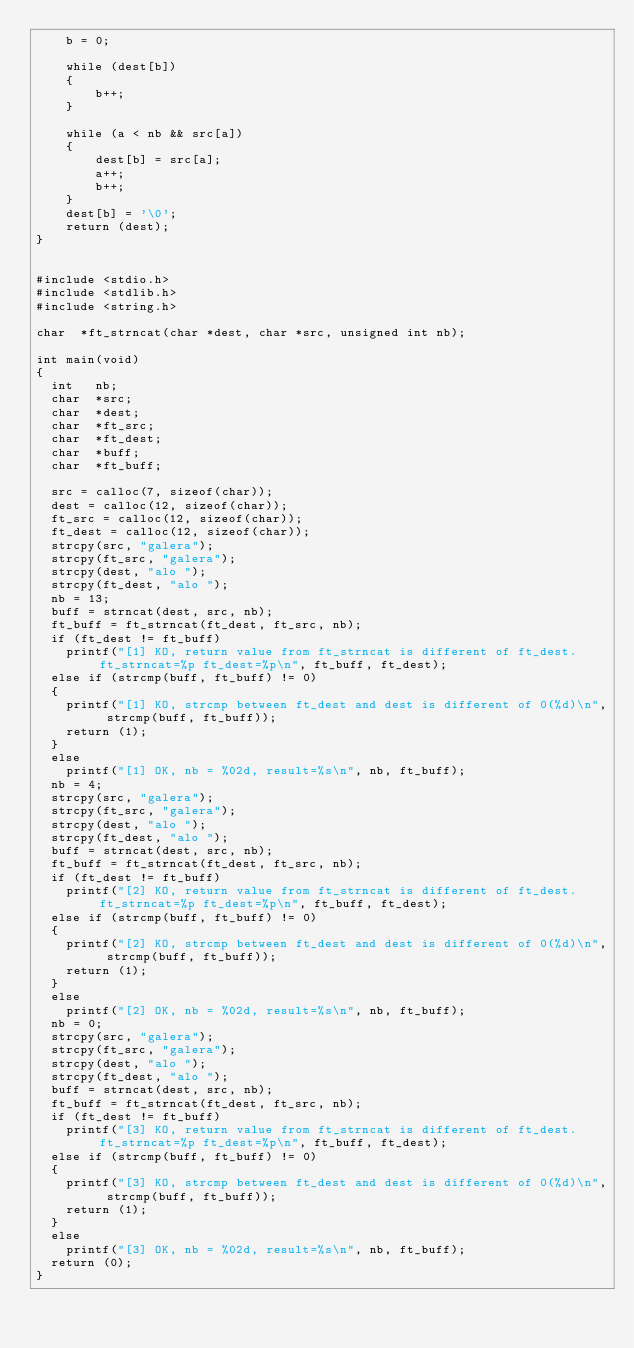<code> <loc_0><loc_0><loc_500><loc_500><_C_>    b = 0;

    while (dest[b])
    {
        b++;
    }

    while (a < nb && src[a])
    {
        dest[b] = src[a];
        a++;
        b++;
    }
    dest[b] = '\0';
    return (dest);
}


#include <stdio.h>
#include <stdlib.h>
#include <string.h>

char	*ft_strncat(char *dest, char *src, unsigned int nb);

int	main(void)
{
	int 	nb;
	char	*src;
	char	*dest;
	char	*ft_src;
	char	*ft_dest;
	char	*buff;
	char	*ft_buff;

	src = calloc(7, sizeof(char));
	dest = calloc(12, sizeof(char));
	ft_src = calloc(12, sizeof(char));
	ft_dest = calloc(12, sizeof(char));
	strcpy(src, "galera");
	strcpy(ft_src, "galera");
	strcpy(dest, "alo ");
	strcpy(ft_dest, "alo ");
	nb = 13;
	buff = strncat(dest, src, nb);
	ft_buff = ft_strncat(ft_dest, ft_src, nb);
	if (ft_dest != ft_buff)
		printf("[1] KO, return value from ft_strncat is different of ft_dest. ft_strncat=%p ft_dest=%p\n", ft_buff, ft_dest);
	else if (strcmp(buff, ft_buff) != 0)
	{
		printf("[1] KO, strcmp between ft_dest and dest is different of 0(%d)\n", strcmp(buff, ft_buff));
		return (1);
	}
	else
		printf("[1] OK, nb = %02d, result=%s\n", nb, ft_buff);
	nb = 4;
	strcpy(src, "galera");
	strcpy(ft_src, "galera");
	strcpy(dest, "alo ");
	strcpy(ft_dest, "alo ");
	buff = strncat(dest, src, nb);
	ft_buff = ft_strncat(ft_dest, ft_src, nb);
	if (ft_dest != ft_buff)
		printf("[2] KO, return value from ft_strncat is different of ft_dest. ft_strncat=%p ft_dest=%p\n", ft_buff, ft_dest);
	else if (strcmp(buff, ft_buff) != 0)
	{
		printf("[2] KO, strcmp between ft_dest and dest is different of 0(%d)\n", strcmp(buff, ft_buff));
		return (1);
	}
	else
		printf("[2] OK, nb = %02d, result=%s\n", nb, ft_buff);
	nb = 0;
	strcpy(src, "galera");
	strcpy(ft_src, "galera");
	strcpy(dest, "alo ");
	strcpy(ft_dest, "alo ");
	buff = strncat(dest, src, nb);
	ft_buff = ft_strncat(ft_dest, ft_src, nb);
	if (ft_dest != ft_buff)
		printf("[3] KO, return value from ft_strncat is different of ft_dest. ft_strncat=%p ft_dest=%p\n", ft_buff, ft_dest);
	else if (strcmp(buff, ft_buff) != 0)
	{
		printf("[3] KO, strcmp between ft_dest and dest is different of 0(%d)\n", strcmp(buff, ft_buff));
		return (1);
	}
	else
		printf("[3] OK, nb = %02d, result=%s\n", nb, ft_buff);
	return (0);
}</code> 